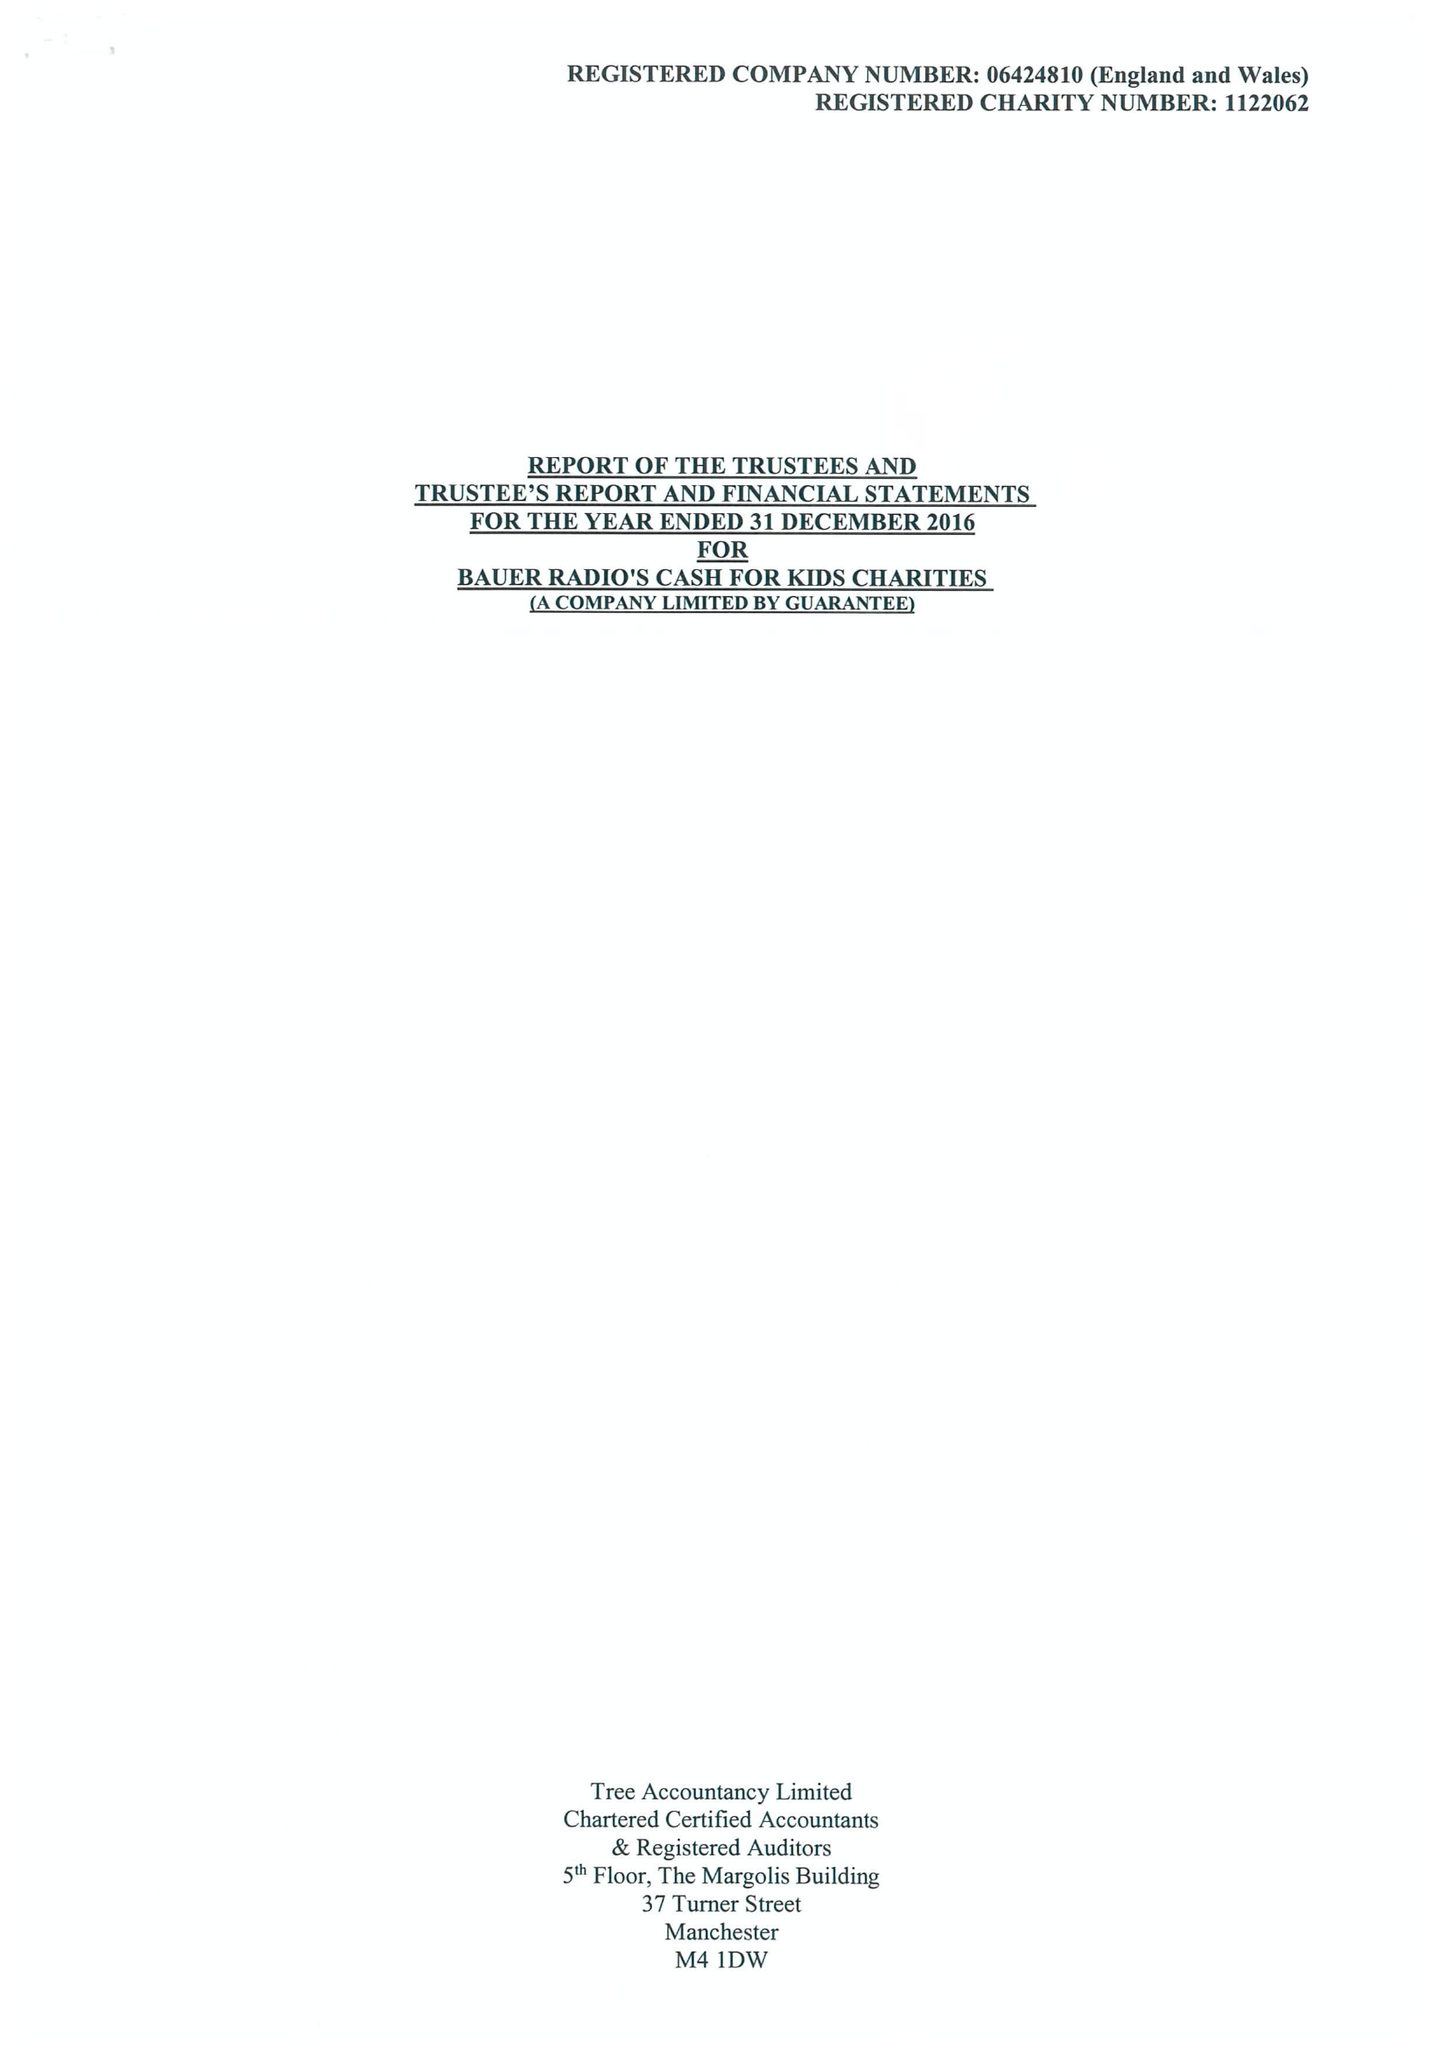What is the value for the spending_annually_in_british_pounds?
Answer the question using a single word or phrase. 15376750.00 